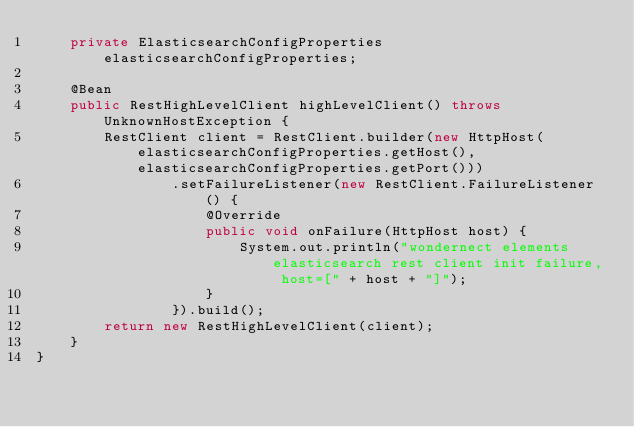Convert code to text. <code><loc_0><loc_0><loc_500><loc_500><_Java_>    private ElasticsearchConfigProperties elasticsearchConfigProperties;

    @Bean
    public RestHighLevelClient highLevelClient() throws UnknownHostException {
        RestClient client = RestClient.builder(new HttpHost(elasticsearchConfigProperties.getHost(), elasticsearchConfigProperties.getPort()))
                .setFailureListener(new RestClient.FailureListener() {
                    @Override
                    public void onFailure(HttpHost host) {
                        System.out.println("wondernect elements elasticsearch rest client init failure, host=[" + host + "]");
                    }
                }).build();
        return new RestHighLevelClient(client);
    }
}
</code> 